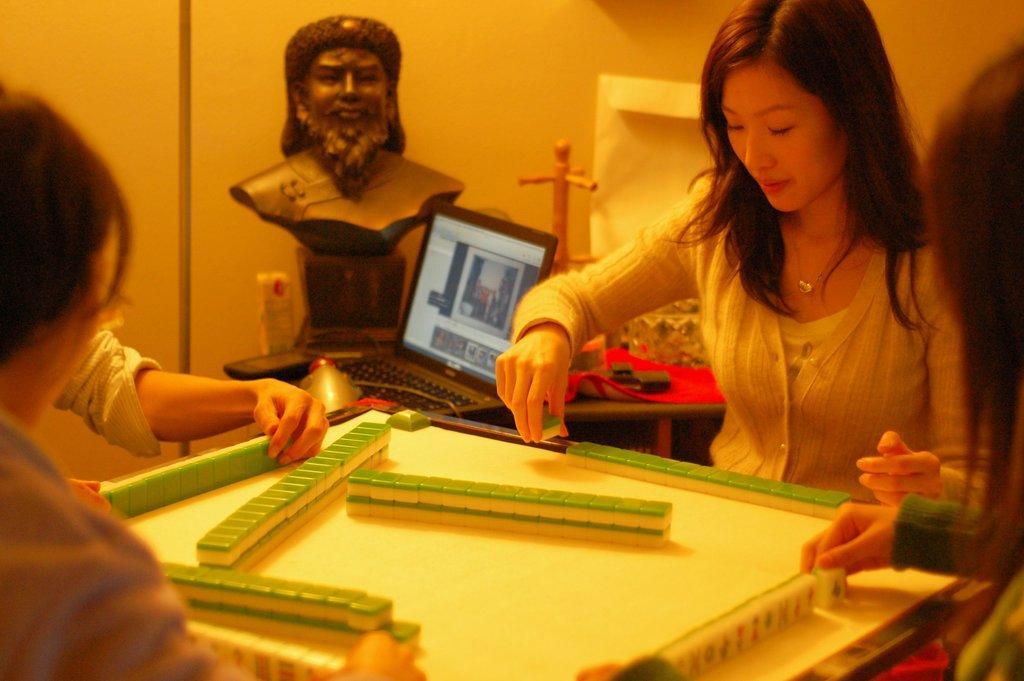Could you give a brief overview of what you see in this image? In this image there are four women playing. In the background there is a person's object, a laptop, a red cloth on the table. In the background there is a plain yellow color wall. 